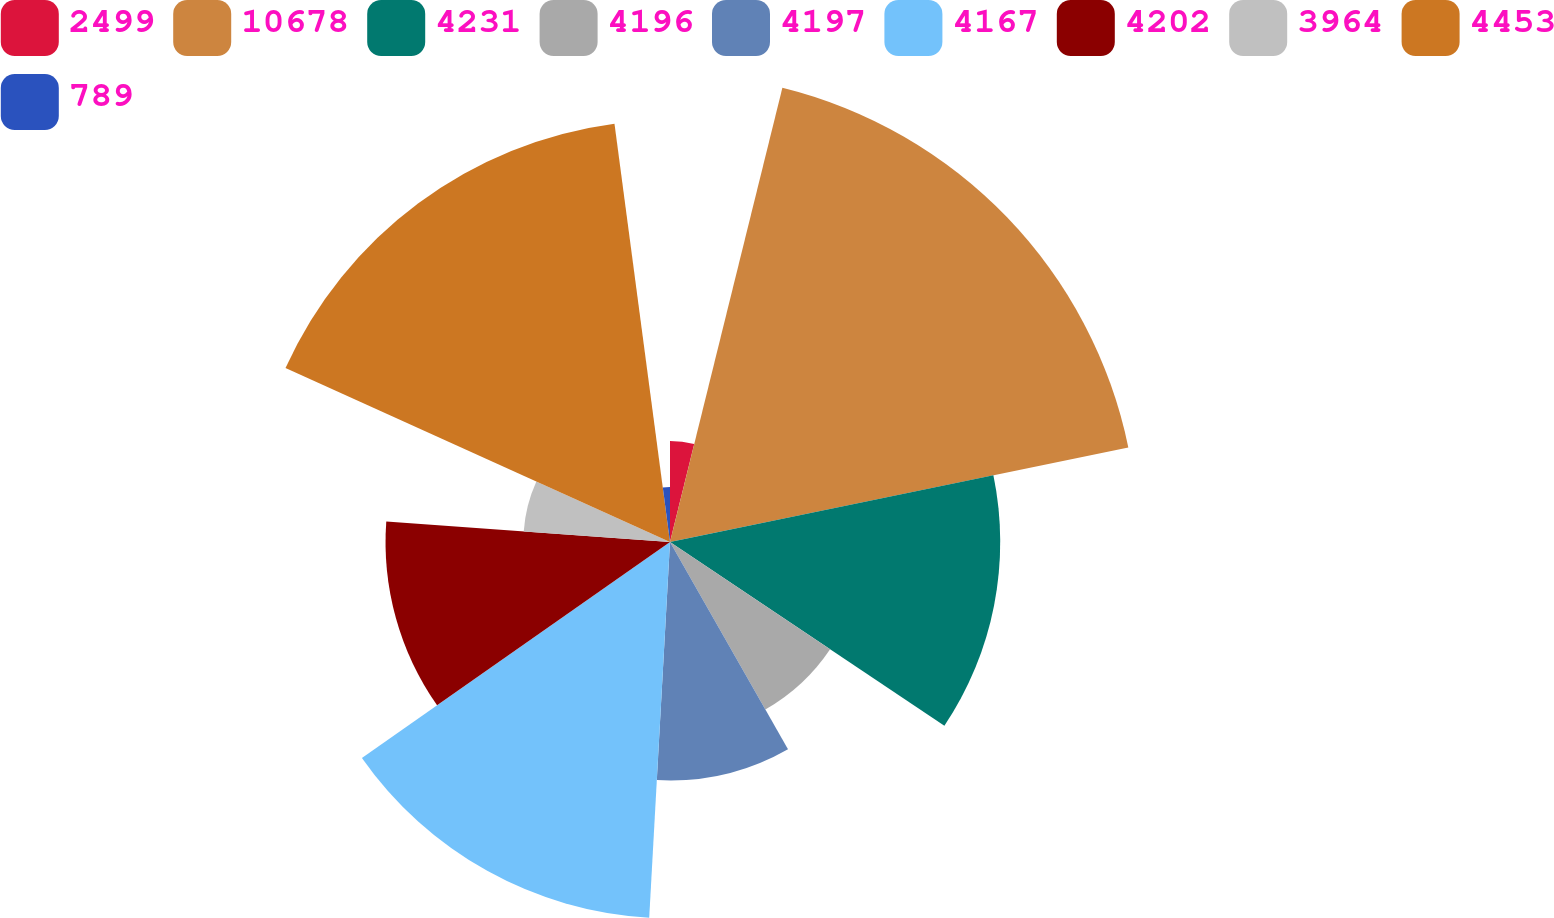Convert chart. <chart><loc_0><loc_0><loc_500><loc_500><pie_chart><fcel>2499<fcel>10678<fcel>4231<fcel>4196<fcel>4197<fcel>4167<fcel>4202<fcel>3964<fcel>4453<fcel>789<nl><fcel>3.86%<fcel>17.9%<fcel>12.63%<fcel>7.37%<fcel>9.12%<fcel>14.39%<fcel>10.88%<fcel>5.61%<fcel>16.14%<fcel>2.1%<nl></chart> 